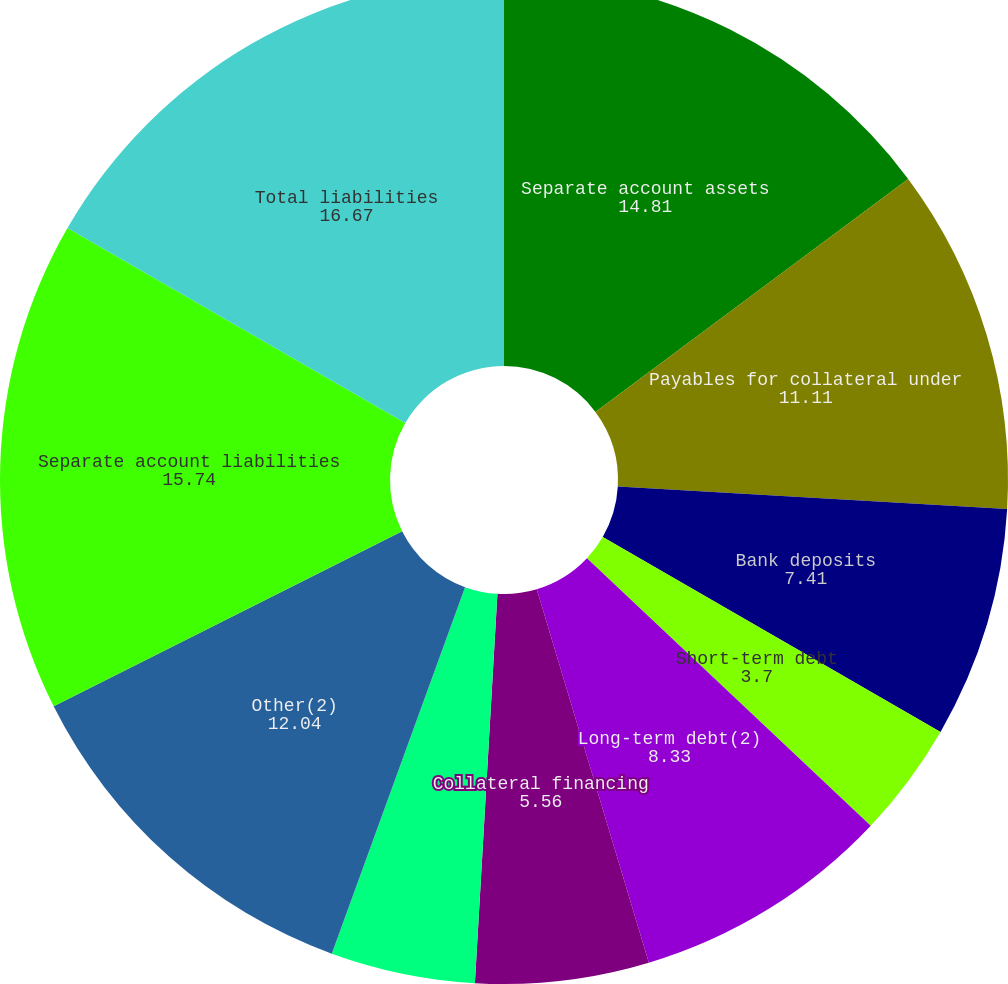Convert chart. <chart><loc_0><loc_0><loc_500><loc_500><pie_chart><fcel>Separate account assets<fcel>Payables for collateral under<fcel>Bank deposits<fcel>Short-term debt<fcel>Long-term debt(2)<fcel>Collateral financing<fcel>Junior subordinated debt<fcel>Other(2)<fcel>Separate account liabilities<fcel>Total liabilities<nl><fcel>14.81%<fcel>11.11%<fcel>7.41%<fcel>3.7%<fcel>8.33%<fcel>5.56%<fcel>4.63%<fcel>12.04%<fcel>15.74%<fcel>16.67%<nl></chart> 